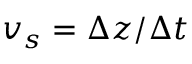<formula> <loc_0><loc_0><loc_500><loc_500>v _ { s } = \Delta z / \Delta t</formula> 